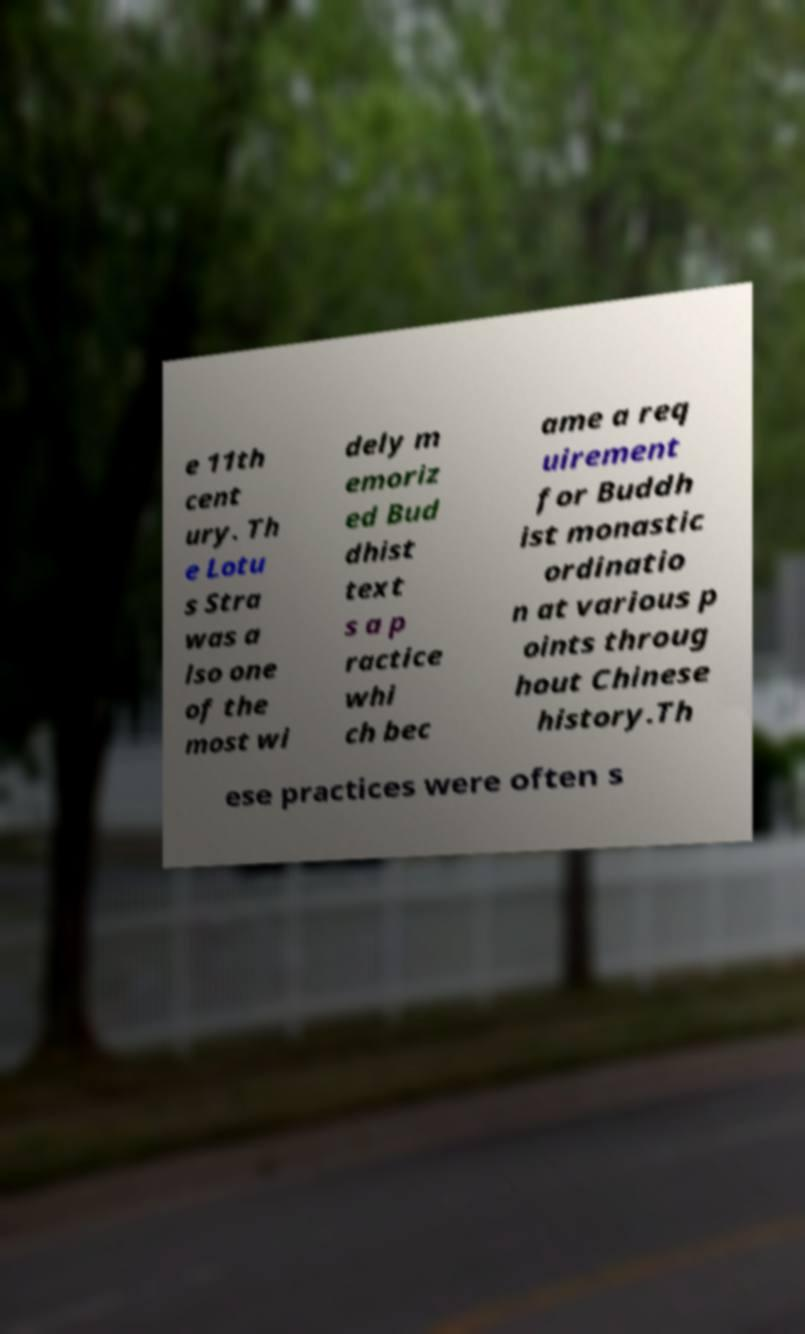Please identify and transcribe the text found in this image. e 11th cent ury. Th e Lotu s Stra was a lso one of the most wi dely m emoriz ed Bud dhist text s a p ractice whi ch bec ame a req uirement for Buddh ist monastic ordinatio n at various p oints throug hout Chinese history.Th ese practices were often s 